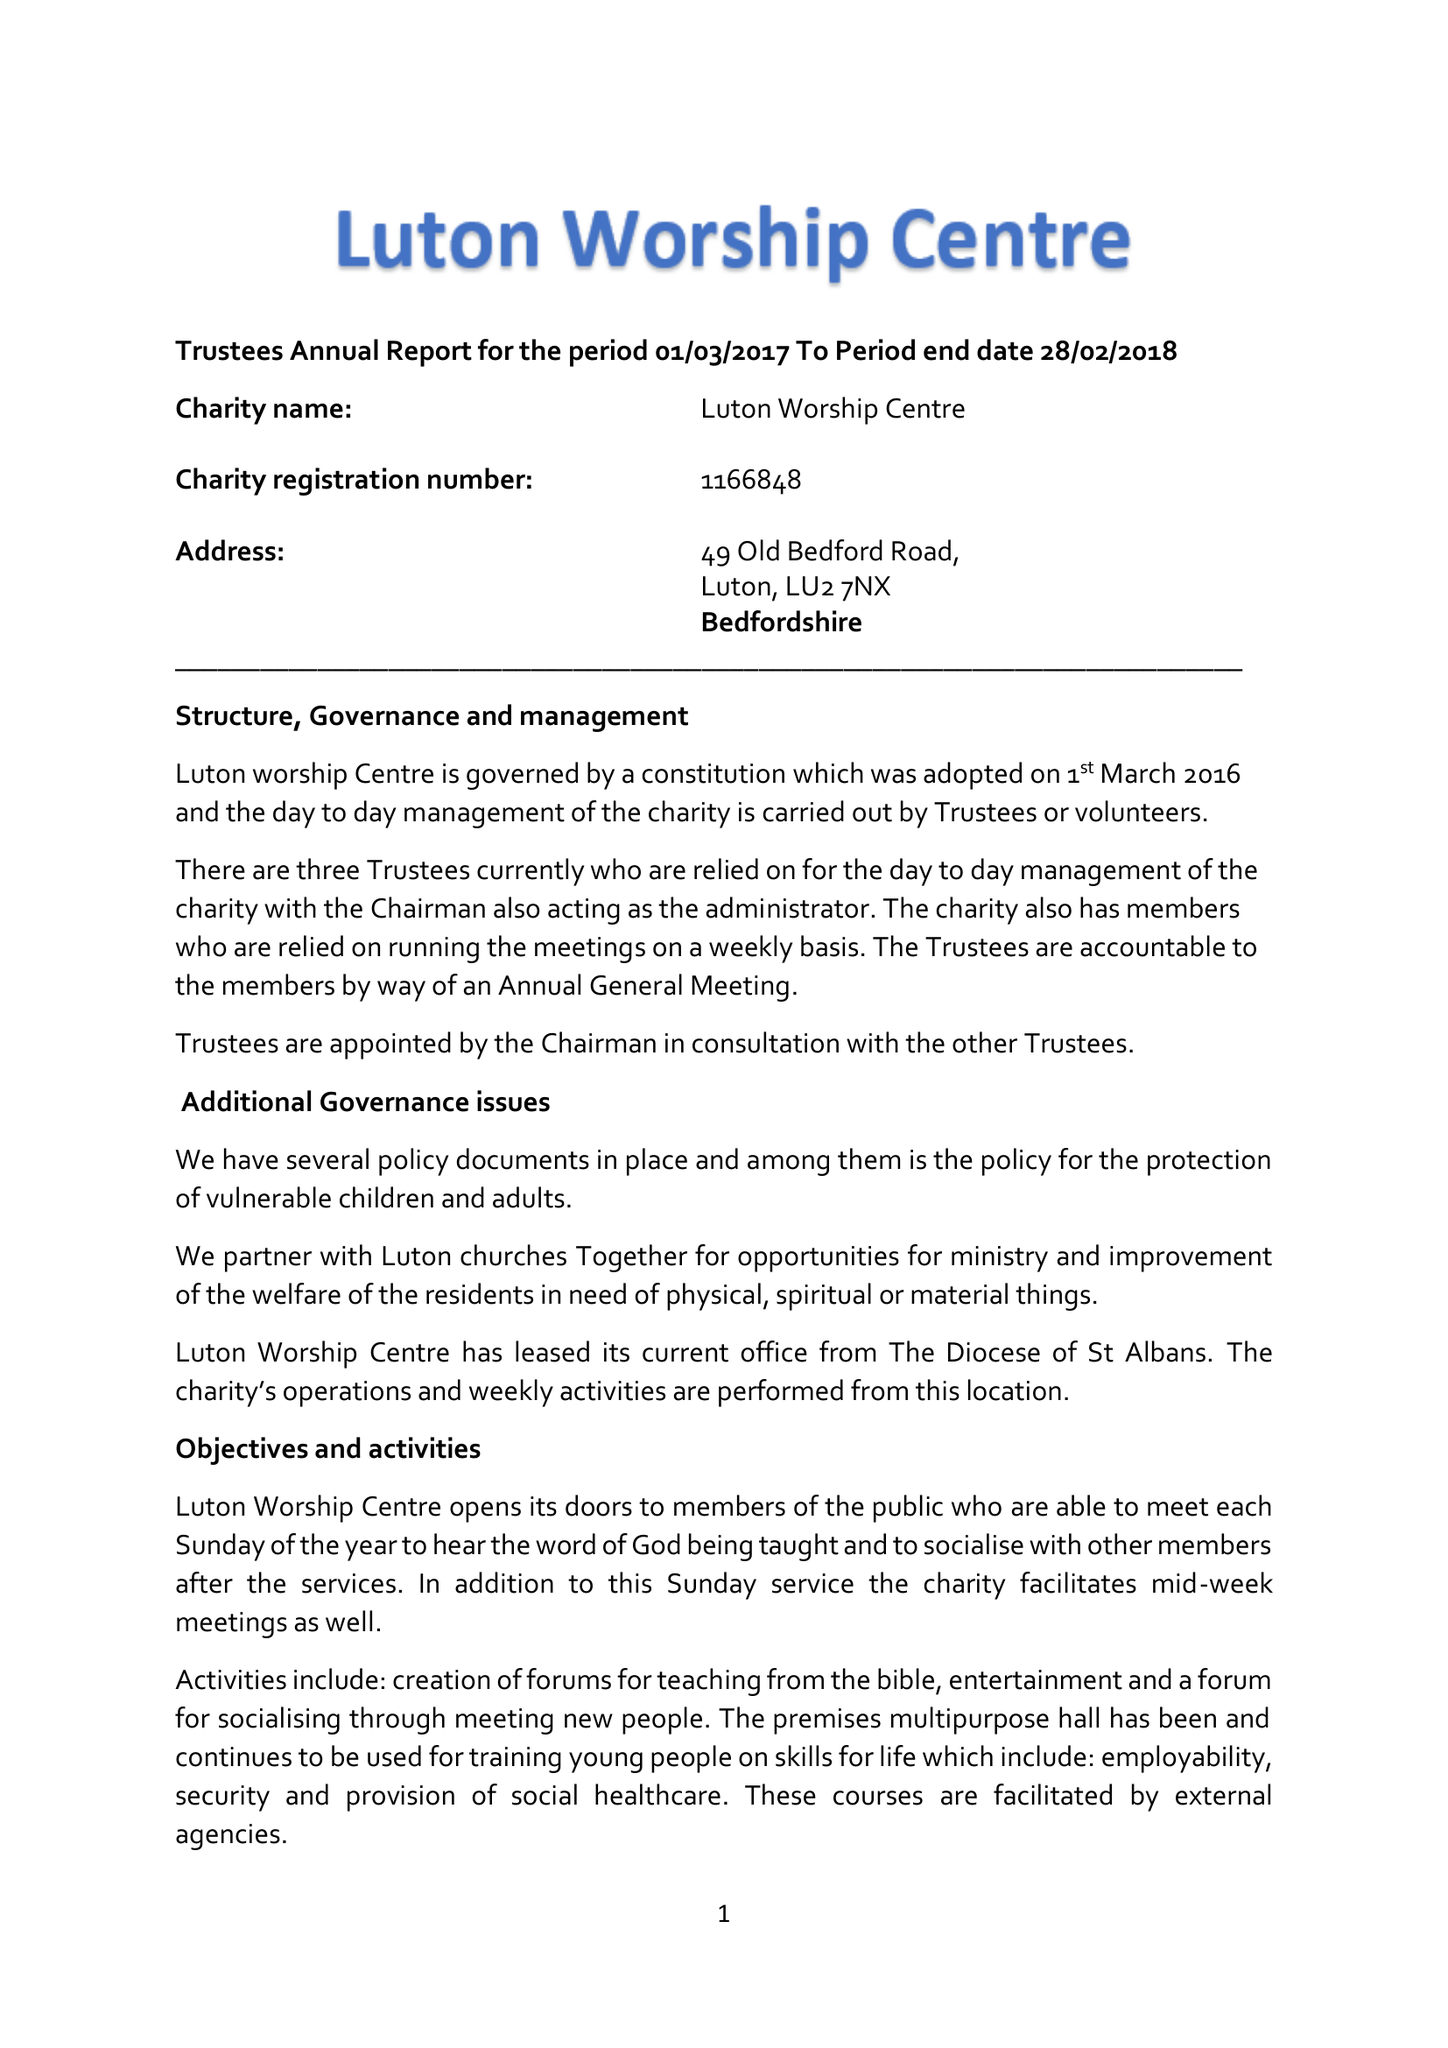What is the value for the address__post_town?
Answer the question using a single word or phrase. LUTON 